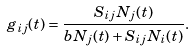<formula> <loc_0><loc_0><loc_500><loc_500>g _ { i j } ( t ) = \frac { S _ { i j } N _ { j } ( t ) } { b N _ { j } ( t ) + S _ { i j } N _ { i } ( t ) } .</formula> 